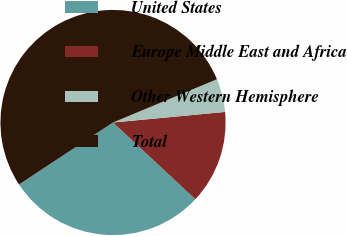Convert chart to OTSL. <chart><loc_0><loc_0><loc_500><loc_500><pie_chart><fcel>United States<fcel>Europe Middle East and Africa<fcel>Other Western Hemisphere<fcel>Total<nl><fcel>28.78%<fcel>13.44%<fcel>4.78%<fcel>53.0%<nl></chart> 